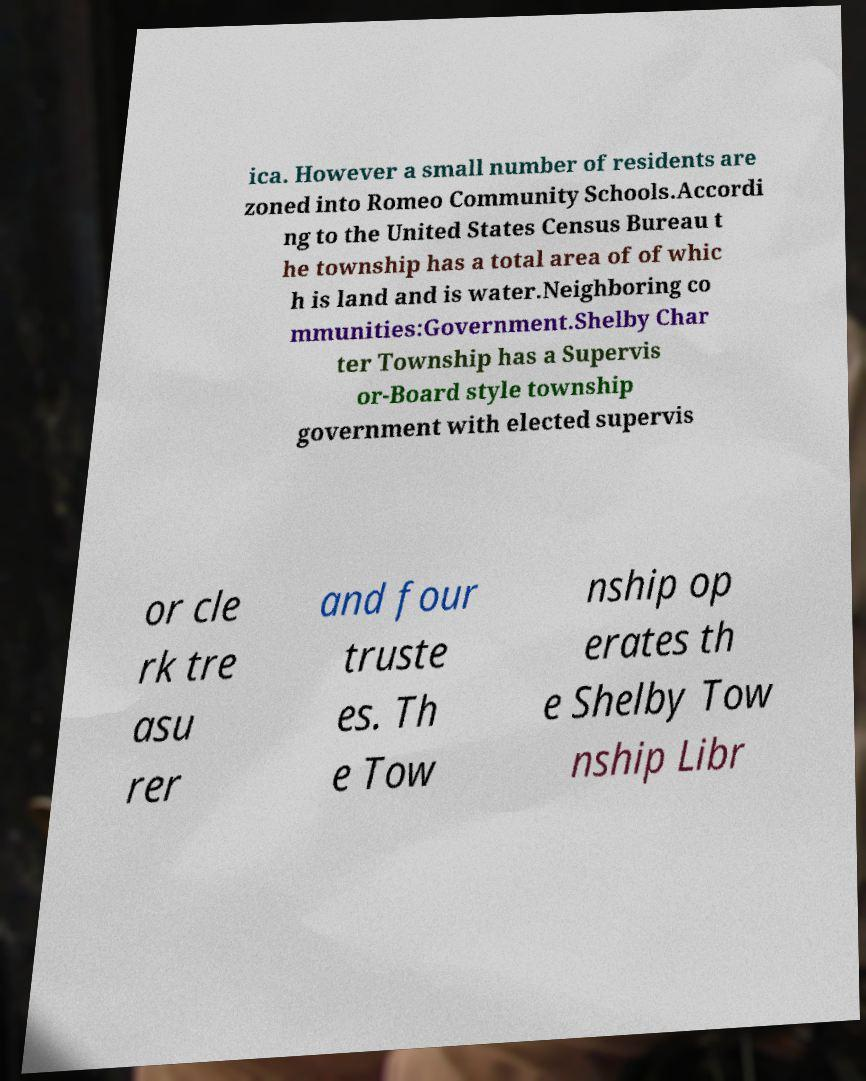Could you extract and type out the text from this image? ica. However a small number of residents are zoned into Romeo Community Schools.Accordi ng to the United States Census Bureau t he township has a total area of of whic h is land and is water.Neighboring co mmunities:Government.Shelby Char ter Township has a Supervis or-Board style township government with elected supervis or cle rk tre asu rer and four truste es. Th e Tow nship op erates th e Shelby Tow nship Libr 